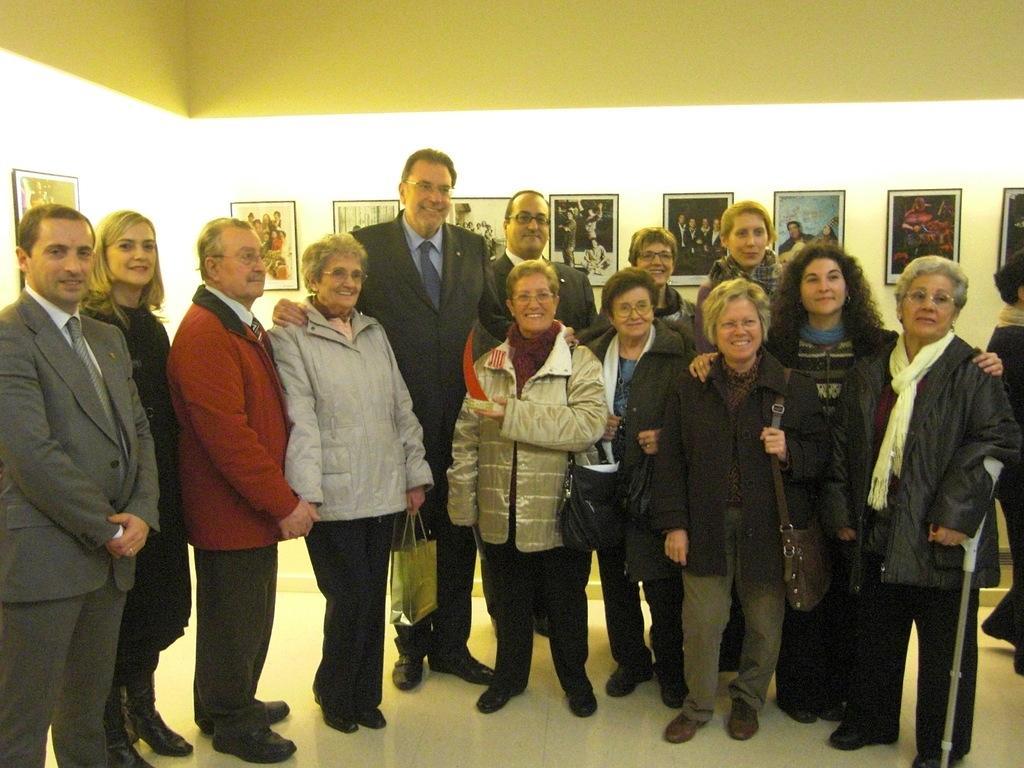Can you describe this image briefly? In this picture we can see a group of people standing on the floor and smiling, hand stick, bags and in the background we can see frames on the wall. 